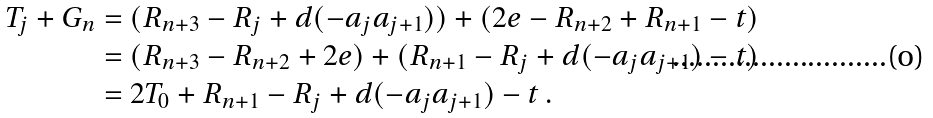<formula> <loc_0><loc_0><loc_500><loc_500>T _ { j } + G _ { n } & = ( R _ { n + 3 } - R _ { j } + d ( - a _ { j } a _ { j + 1 } ) ) + ( 2 e - R _ { n + 2 } + R _ { n + 1 } - t ) \\ & = ( R _ { n + 3 } - R _ { n + 2 } + 2 e ) + ( R _ { n + 1 } - R _ { j } + d ( - a _ { j } a _ { j + 1 } ) - t ) \\ & = 2 T _ { 0 } + R _ { n + 1 } - R _ { j } + d ( - a _ { j } a _ { j + 1 } ) - t \, .</formula> 